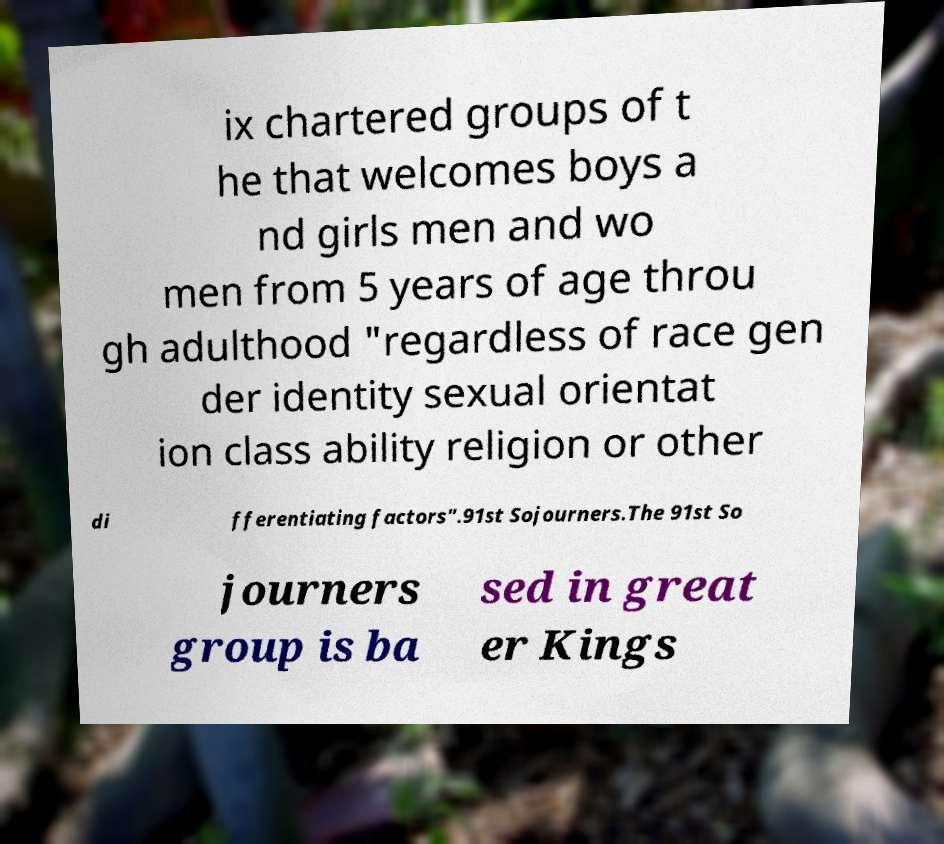Can you read and provide the text displayed in the image?This photo seems to have some interesting text. Can you extract and type it out for me? ix chartered groups of t he that welcomes boys a nd girls men and wo men from 5 years of age throu gh adulthood "regardless of race gen der identity sexual orientat ion class ability religion or other di fferentiating factors".91st Sojourners.The 91st So journers group is ba sed in great er Kings 